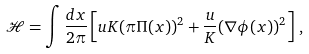Convert formula to latex. <formula><loc_0><loc_0><loc_500><loc_500>\mathcal { H } = \int \frac { d x } { 2 \pi } \left [ u K ( \pi \Pi ( x ) ) ^ { 2 } + \frac { u } { K } ( \nabla \phi ( x ) ) ^ { 2 } \right ] \, ,</formula> 